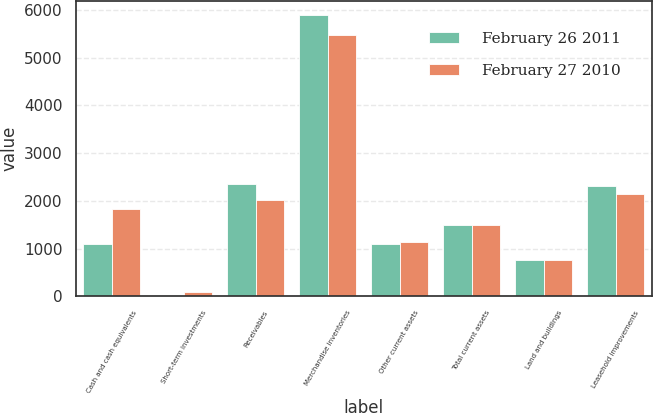Convert chart to OTSL. <chart><loc_0><loc_0><loc_500><loc_500><stacked_bar_chart><ecel><fcel>Cash and cash equivalents<fcel>Short-term investments<fcel>Receivables<fcel>Merchandise inventories<fcel>Other current assets<fcel>Total current assets<fcel>Land and buildings<fcel>Leasehold improvements<nl><fcel>February 26 2011<fcel>1103<fcel>22<fcel>2348<fcel>5897<fcel>1103<fcel>1485<fcel>766<fcel>2318<nl><fcel>February 27 2010<fcel>1826<fcel>90<fcel>2020<fcel>5486<fcel>1144<fcel>1485<fcel>757<fcel>2154<nl></chart> 